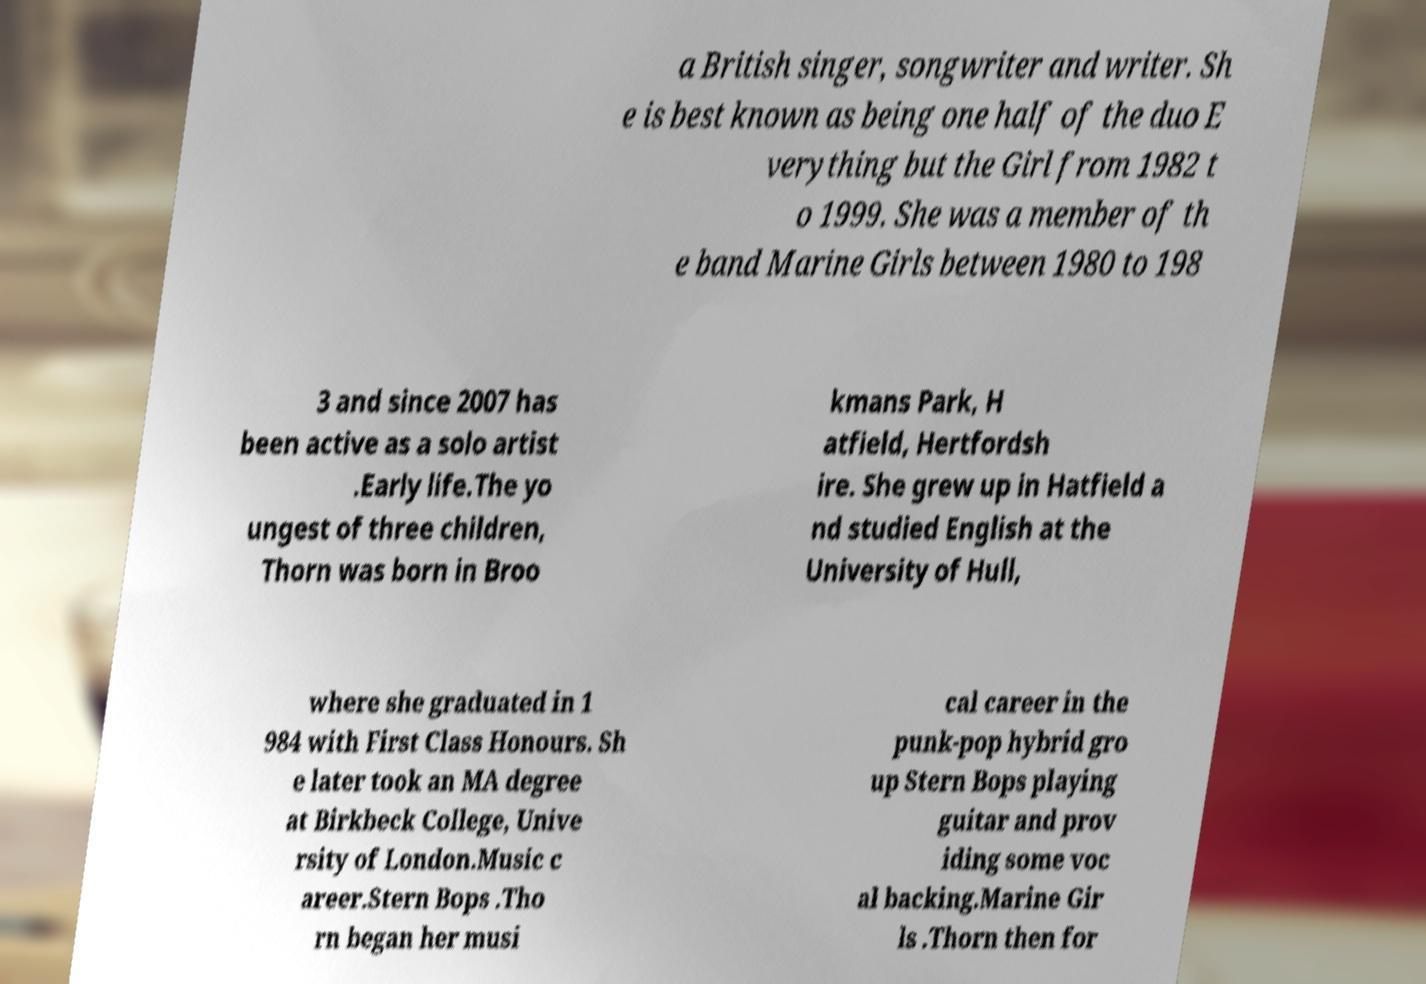Can you accurately transcribe the text from the provided image for me? a British singer, songwriter and writer. Sh e is best known as being one half of the duo E verything but the Girl from 1982 t o 1999. She was a member of th e band Marine Girls between 1980 to 198 3 and since 2007 has been active as a solo artist .Early life.The yo ungest of three children, Thorn was born in Broo kmans Park, H atfield, Hertfordsh ire. She grew up in Hatfield a nd studied English at the University of Hull, where she graduated in 1 984 with First Class Honours. Sh e later took an MA degree at Birkbeck College, Unive rsity of London.Music c areer.Stern Bops .Tho rn began her musi cal career in the punk-pop hybrid gro up Stern Bops playing guitar and prov iding some voc al backing.Marine Gir ls .Thorn then for 